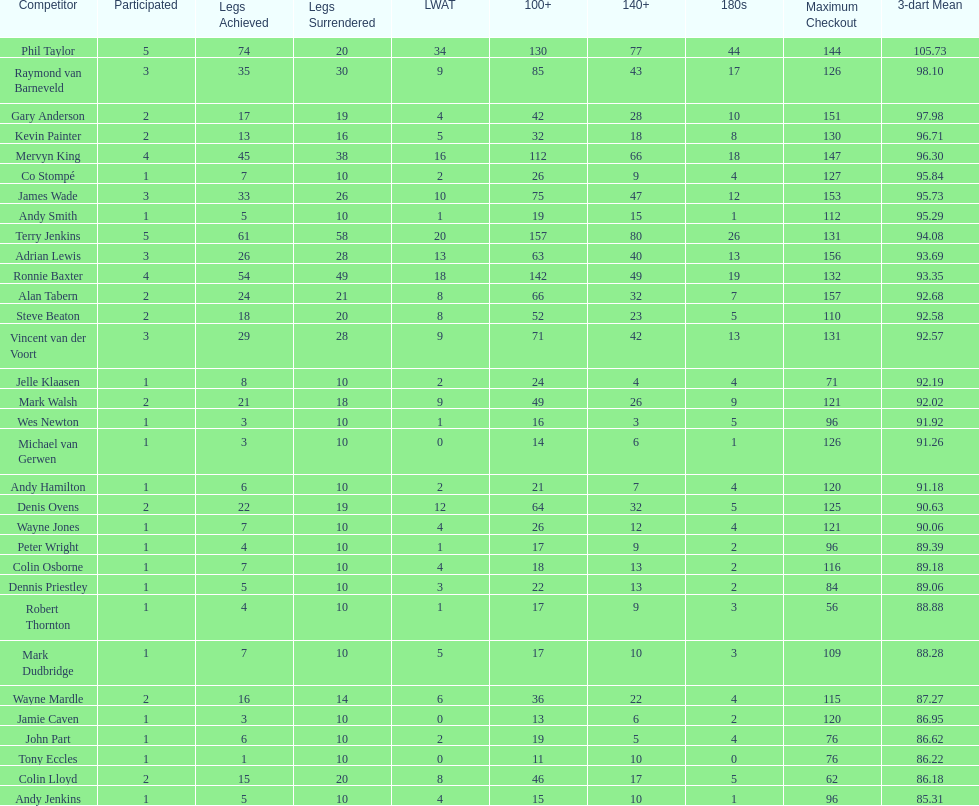Give me the full table as a dictionary. {'header': ['Competitor', 'Participated', 'Legs Achieved', 'Legs Surrendered', 'LWAT', '100+', '140+', '180s', 'Maximum Checkout', '3-dart Mean'], 'rows': [['Phil Taylor', '5', '74', '20', '34', '130', '77', '44', '144', '105.73'], ['Raymond van Barneveld', '3', '35', '30', '9', '85', '43', '17', '126', '98.10'], ['Gary Anderson', '2', '17', '19', '4', '42', '28', '10', '151', '97.98'], ['Kevin Painter', '2', '13', '16', '5', '32', '18', '8', '130', '96.71'], ['Mervyn King', '4', '45', '38', '16', '112', '66', '18', '147', '96.30'], ['Co Stompé', '1', '7', '10', '2', '26', '9', '4', '127', '95.84'], ['James Wade', '3', '33', '26', '10', '75', '47', '12', '153', '95.73'], ['Andy Smith', '1', '5', '10', '1', '19', '15', '1', '112', '95.29'], ['Terry Jenkins', '5', '61', '58', '20', '157', '80', '26', '131', '94.08'], ['Adrian Lewis', '3', '26', '28', '13', '63', '40', '13', '156', '93.69'], ['Ronnie Baxter', '4', '54', '49', '18', '142', '49', '19', '132', '93.35'], ['Alan Tabern', '2', '24', '21', '8', '66', '32', '7', '157', '92.68'], ['Steve Beaton', '2', '18', '20', '8', '52', '23', '5', '110', '92.58'], ['Vincent van der Voort', '3', '29', '28', '9', '71', '42', '13', '131', '92.57'], ['Jelle Klaasen', '1', '8', '10', '2', '24', '4', '4', '71', '92.19'], ['Mark Walsh', '2', '21', '18', '9', '49', '26', '9', '121', '92.02'], ['Wes Newton', '1', '3', '10', '1', '16', '3', '5', '96', '91.92'], ['Michael van Gerwen', '1', '3', '10', '0', '14', '6', '1', '126', '91.26'], ['Andy Hamilton', '1', '6', '10', '2', '21', '7', '4', '120', '91.18'], ['Denis Ovens', '2', '22', '19', '12', '64', '32', '5', '125', '90.63'], ['Wayne Jones', '1', '7', '10', '4', '26', '12', '4', '121', '90.06'], ['Peter Wright', '1', '4', '10', '1', '17', '9', '2', '96', '89.39'], ['Colin Osborne', '1', '7', '10', '4', '18', '13', '2', '116', '89.18'], ['Dennis Priestley', '1', '5', '10', '3', '22', '13', '2', '84', '89.06'], ['Robert Thornton', '1', '4', '10', '1', '17', '9', '3', '56', '88.88'], ['Mark Dudbridge', '1', '7', '10', '5', '17', '10', '3', '109', '88.28'], ['Wayne Mardle', '2', '16', '14', '6', '36', '22', '4', '115', '87.27'], ['Jamie Caven', '1', '3', '10', '0', '13', '6', '2', '120', '86.95'], ['John Part', '1', '6', '10', '2', '19', '5', '4', '76', '86.62'], ['Tony Eccles', '1', '1', '10', '0', '11', '10', '0', '76', '86.22'], ['Colin Lloyd', '2', '15', '20', '8', '46', '17', '5', '62', '86.18'], ['Andy Jenkins', '1', '5', '10', '4', '15', '10', '1', '96', '85.31']]} Was andy smith or kevin painter's 3-dart average 96.71? Kevin Painter. 